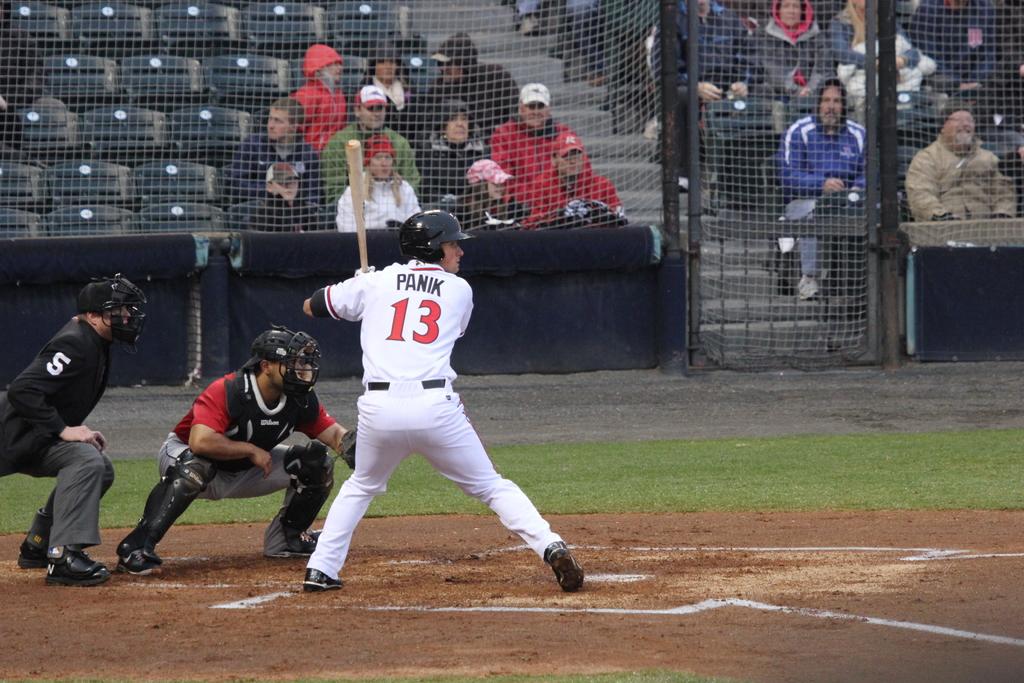What player is at bat?
Your response must be concise. Panik. What number is the player that is batting?
Keep it short and to the point. 13. 